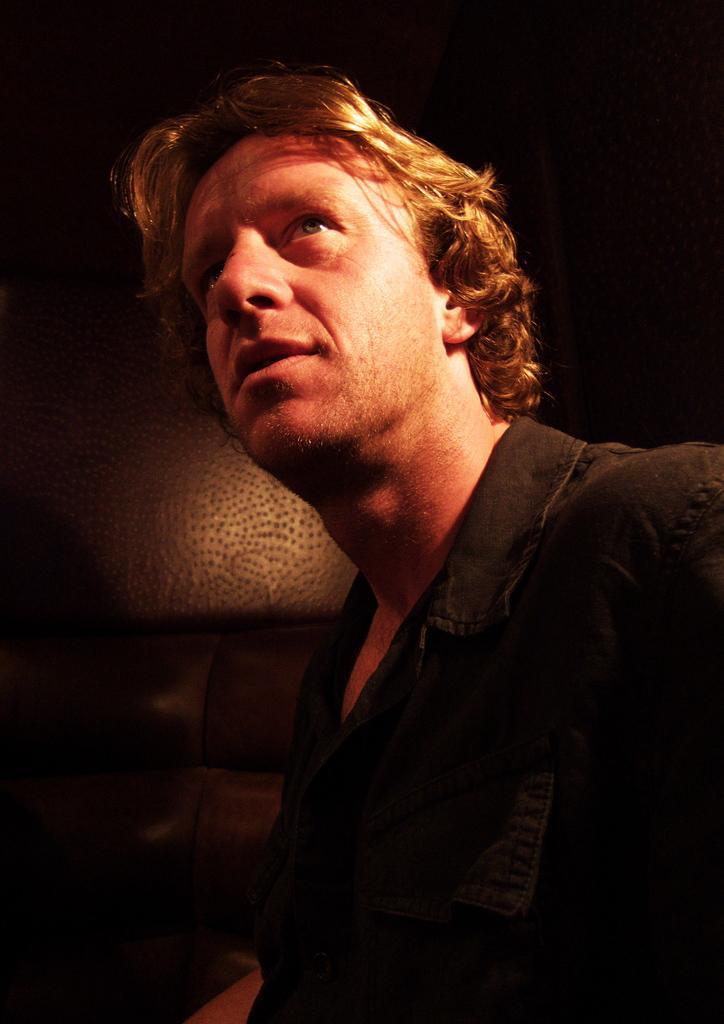How would you summarize this image in a sentence or two? This picture shows a man and we see a light on his face and he wore a black color shirt. 